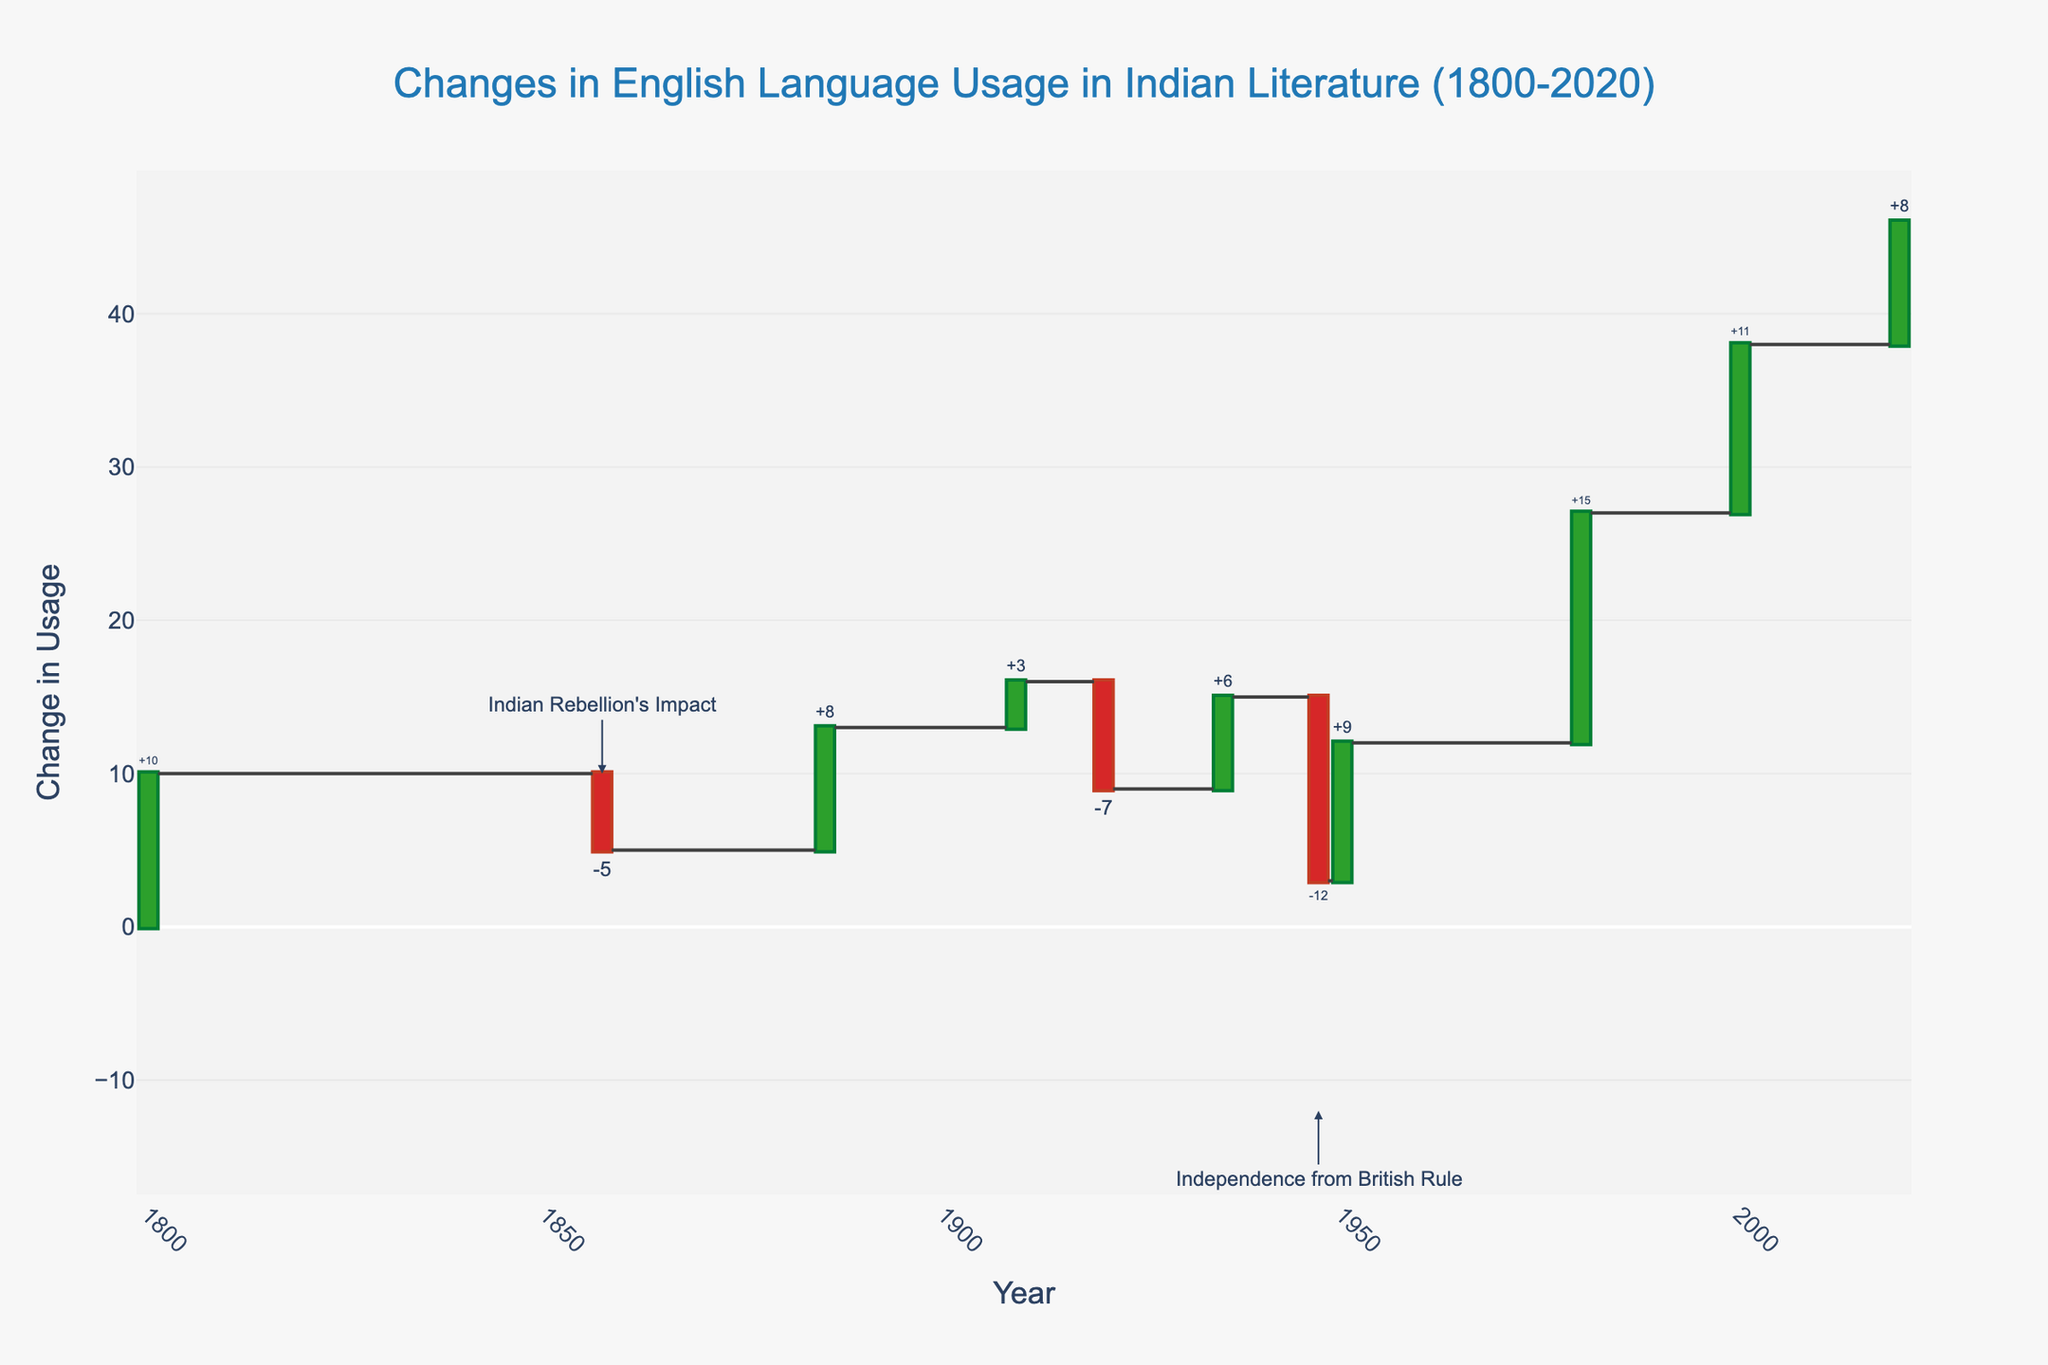What is the title of the waterfall chart? The title of a chart is usually displayed prominently at the top of the figure, helping viewers quickly understand what the data represents. In this figure, the title is clearly stated at the top in bold and larger font compared to other elements.
Answer: Changes in English Language Usage in Indian Literature (1800-2020) How does the Indian Rebellion of 1857 impact English language usage? Look at the specific data point for the year 1857, which shows a negative change (a decrease). The corresponding annotation within the chart also provides context for this impact.
Answer: -5 What is the total change in English language usage from 1800 to 2020? The total change is explicitly labeled at the end of the chart, combining all individual changes throughout the years into a single cumulative value.
Answer: 46 Compare the impact of the rise of Postcolonial Literature in 1980 to the impact of the digital age and social media in 2020. Which had a greater influence? Locate both data points on the chart. The height and value represented by each bar in these years show that the rise of Postcolonial Literature had a 15-point increase, while the digital age in 2020 had an 8-point increase.
Answer: Postcolonial Literature (1980) How many times did the English language usage experience a negative change? Identify and count the bars that extend downward, indicating a decrease in usage. There are three such instances in the years 1857 (-5), 1920 (-7), and 1947 (-12).
Answer: 3 What can be inferred from the change in 1947 when India gained independence from British rule? The chart shows a significant negative change in 1947, indicated by a large downward bar. Additionally, an annotation highlights the importance of this year, suggesting a marked reduction in English usage immediately following independence.
Answer: A significant decline Which event caused the largest increase in English language usage? Examine all the upward bars to find the one with the greatest height. The formation of the Indian National Congress in 1885 is the event associated with an 8-point increase.
Answer: Formation of Indian National Congress (1885) Calculate the average change in English language usage across all the specified events from 1800 to 2020, excluding the total. Sum all the individual changes: 10 + (-5) + 8 + 3 + (-7) + 6 + (-12) + 9 + 15 + 11 + 8 = 46. The number of events is 10, thus the average change is 46/10.
Answer: 4.6 Which year's change appears to be closest to the overall average change determined previously? Compare each year's change to the calculated average of 4.6. The year 1909, with a change of 3, is the closest to this average.
Answer: 1909 